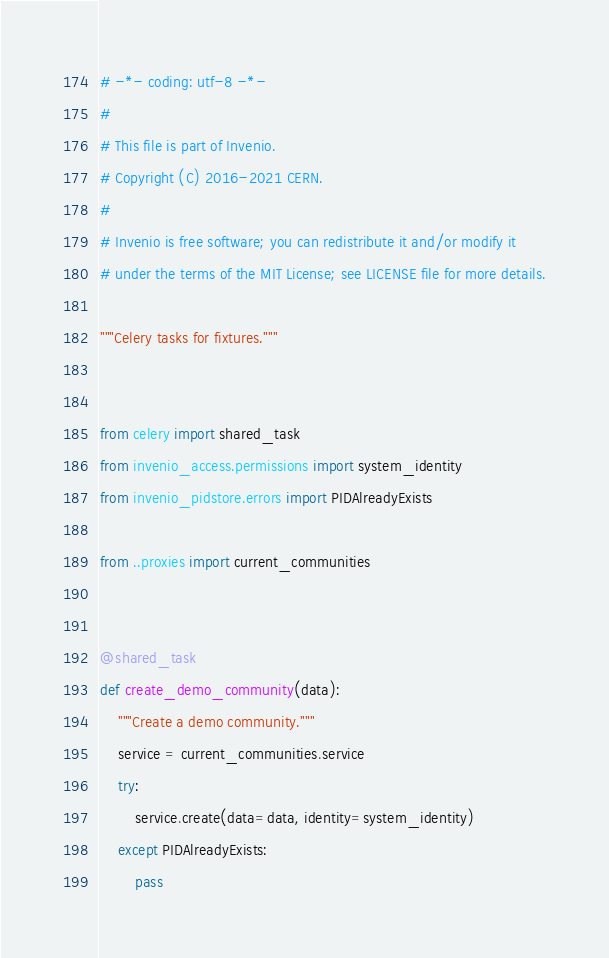<code> <loc_0><loc_0><loc_500><loc_500><_Python_># -*- coding: utf-8 -*-
#
# This file is part of Invenio.
# Copyright (C) 2016-2021 CERN.
#
# Invenio is free software; you can redistribute it and/or modify it
# under the terms of the MIT License; see LICENSE file for more details.

"""Celery tasks for fixtures."""


from celery import shared_task
from invenio_access.permissions import system_identity
from invenio_pidstore.errors import PIDAlreadyExists

from ..proxies import current_communities


@shared_task
def create_demo_community(data):
    """Create a demo community."""
    service = current_communities.service
    try:
        service.create(data=data, identity=system_identity)
    except PIDAlreadyExists:
        pass
</code> 